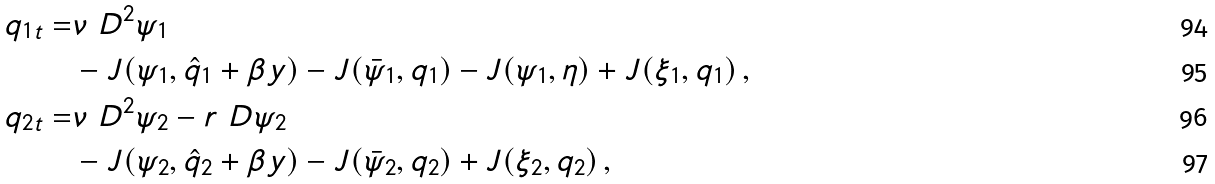<formula> <loc_0><loc_0><loc_500><loc_500>q _ { 1 t } = & \nu \ D ^ { 2 } \psi _ { 1 } \\ & - J ( \psi _ { 1 } , \hat { q } _ { 1 } + \beta y ) - J ( \bar { \psi } _ { 1 } , q _ { 1 } ) - J ( \psi _ { 1 } , \eta ) + J ( \xi _ { 1 } , q _ { 1 } ) \, , \\ q _ { 2 t } = & \nu \ D ^ { 2 } \psi _ { 2 } - r \ D \psi _ { 2 } \\ & - J ( \psi _ { 2 } , \hat { q } _ { 2 } + \beta y ) - J ( \bar { \psi } _ { 2 } , q _ { 2 } ) + J ( \xi _ { 2 } , q _ { 2 } ) \, ,</formula> 